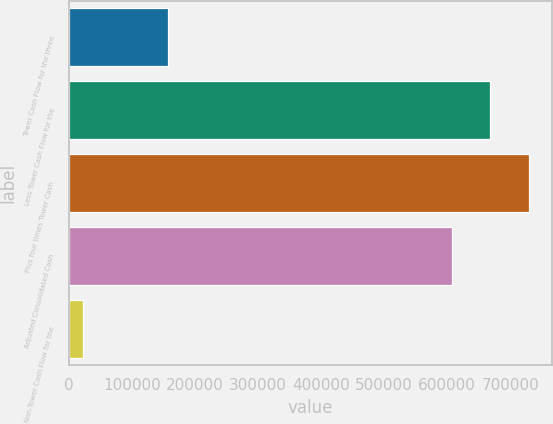<chart> <loc_0><loc_0><loc_500><loc_500><bar_chart><fcel>Tower Cash Flow for the three<fcel>Less Tower Cash Flow for the<fcel>Plus four times Tower Cash<fcel>Adjusted Consolidated Cash<fcel>Non-Tower Cash Flow for the<nl><fcel>157311<fcel>668591<fcel>729254<fcel>607928<fcel>22614<nl></chart> 